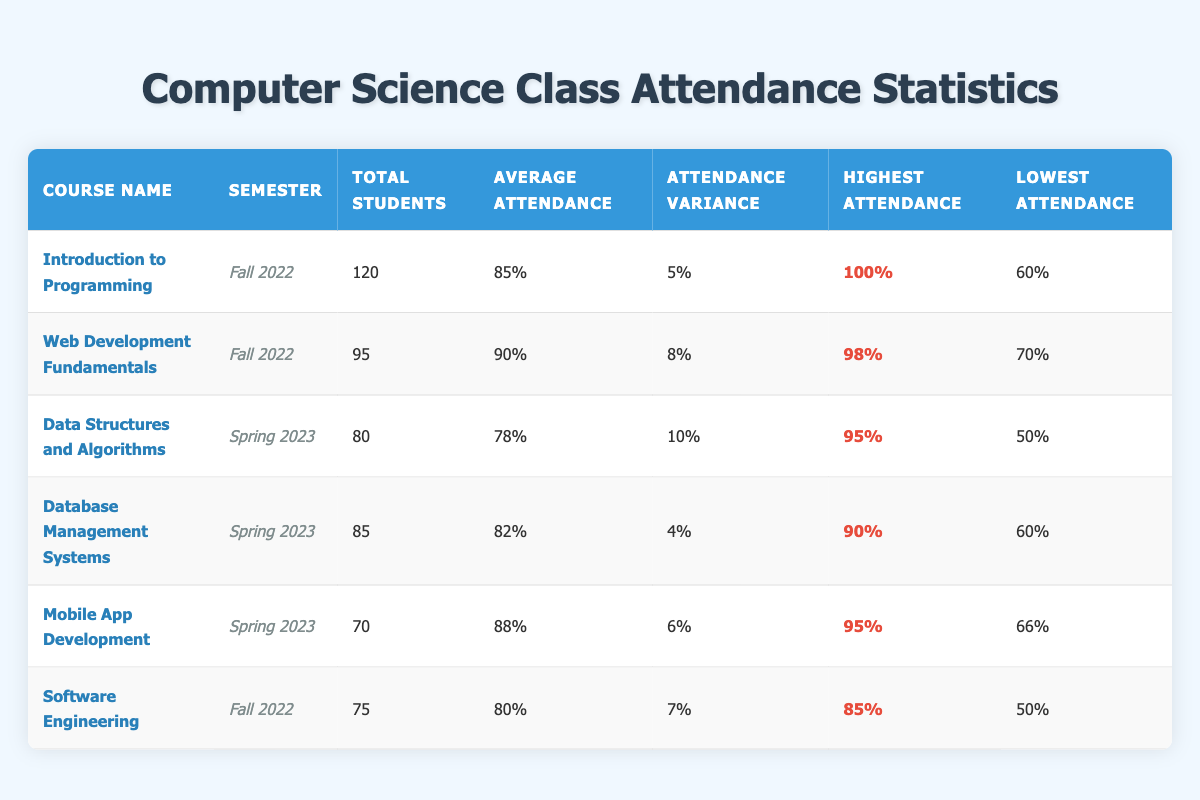What is the total number of students enrolled in "Web Development Fundamentals"? The table shows the course "Web Development Fundamentals" with a total of 95 students enrolled.
Answer: 95 What was the average attendance for the "Database Management Systems" course? According to the table, the average attendance for "Database Management Systems" is listed as 82%.
Answer: 82% Which course had the highest recorded attendance? The table indicates that "Introduction to Programming" had the highest recorded attendance at 100%.
Answer: 100% What is the variance of attendance for "Data Structures and Algorithms"? The attendance variance for "Data Structures and Algorithms" is provided in the table as 10%.
Answer: 10% How many courses had an average attendance above 85%? The courses with average attendance above 85% are "Web Development Fundamentals" (90%), "Introduction to Programming" (85%), and "Mobile App Development" (88%). This makes a total of 3 courses.
Answer: 3 Was the lowest attendance in the "Software Engineering" course above 50%? The table shows that the lowest attendance for "Software Engineering" is 50%, which means it was not above 50%.
Answer: No What is the difference between the highest attendance in "Mobile App Development" and the lowest attendance in "Data Structures and Algorithms"? The highest attendance in "Mobile App Development" is 95% and the lowest in "Data Structures and Algorithms" is 50%. Therefore, the difference is calculated as 95% - 50% = 45%.
Answer: 45% Which semester had the highest average attendance across all courses? Calculating the average attendance for Fall 2022 courses: (85% + 90% + 80%)/3 = 85%. For Spring 2023: (78% + 82% + 88%)/3 = 82.67%. The Fall 2022 semester had the highest average attendance at 85%.
Answer: Fall 2022 Is the total number of students in "Mobile App Development" less than those in "Database Management Systems"? The table states that "Mobile App Development" has 70 students, while "Database Management Systems" has 85 students; therefore, 70 is less than 85.
Answer: Yes What is the average of all the highest attendance rates represented in the table? The highest attendances are 100%, 98%, 95%, 90%, 95%, and 85%. Adding these up gives 100 + 98 + 95 + 90 + 95 + 85 = 563%. Dividing by the number of courses (6), the average highest attendance is 563% / 6 = approximately 93.83%.
Answer: Approximately 93.83% 